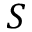Convert formula to latex. <formula><loc_0><loc_0><loc_500><loc_500>S</formula> 